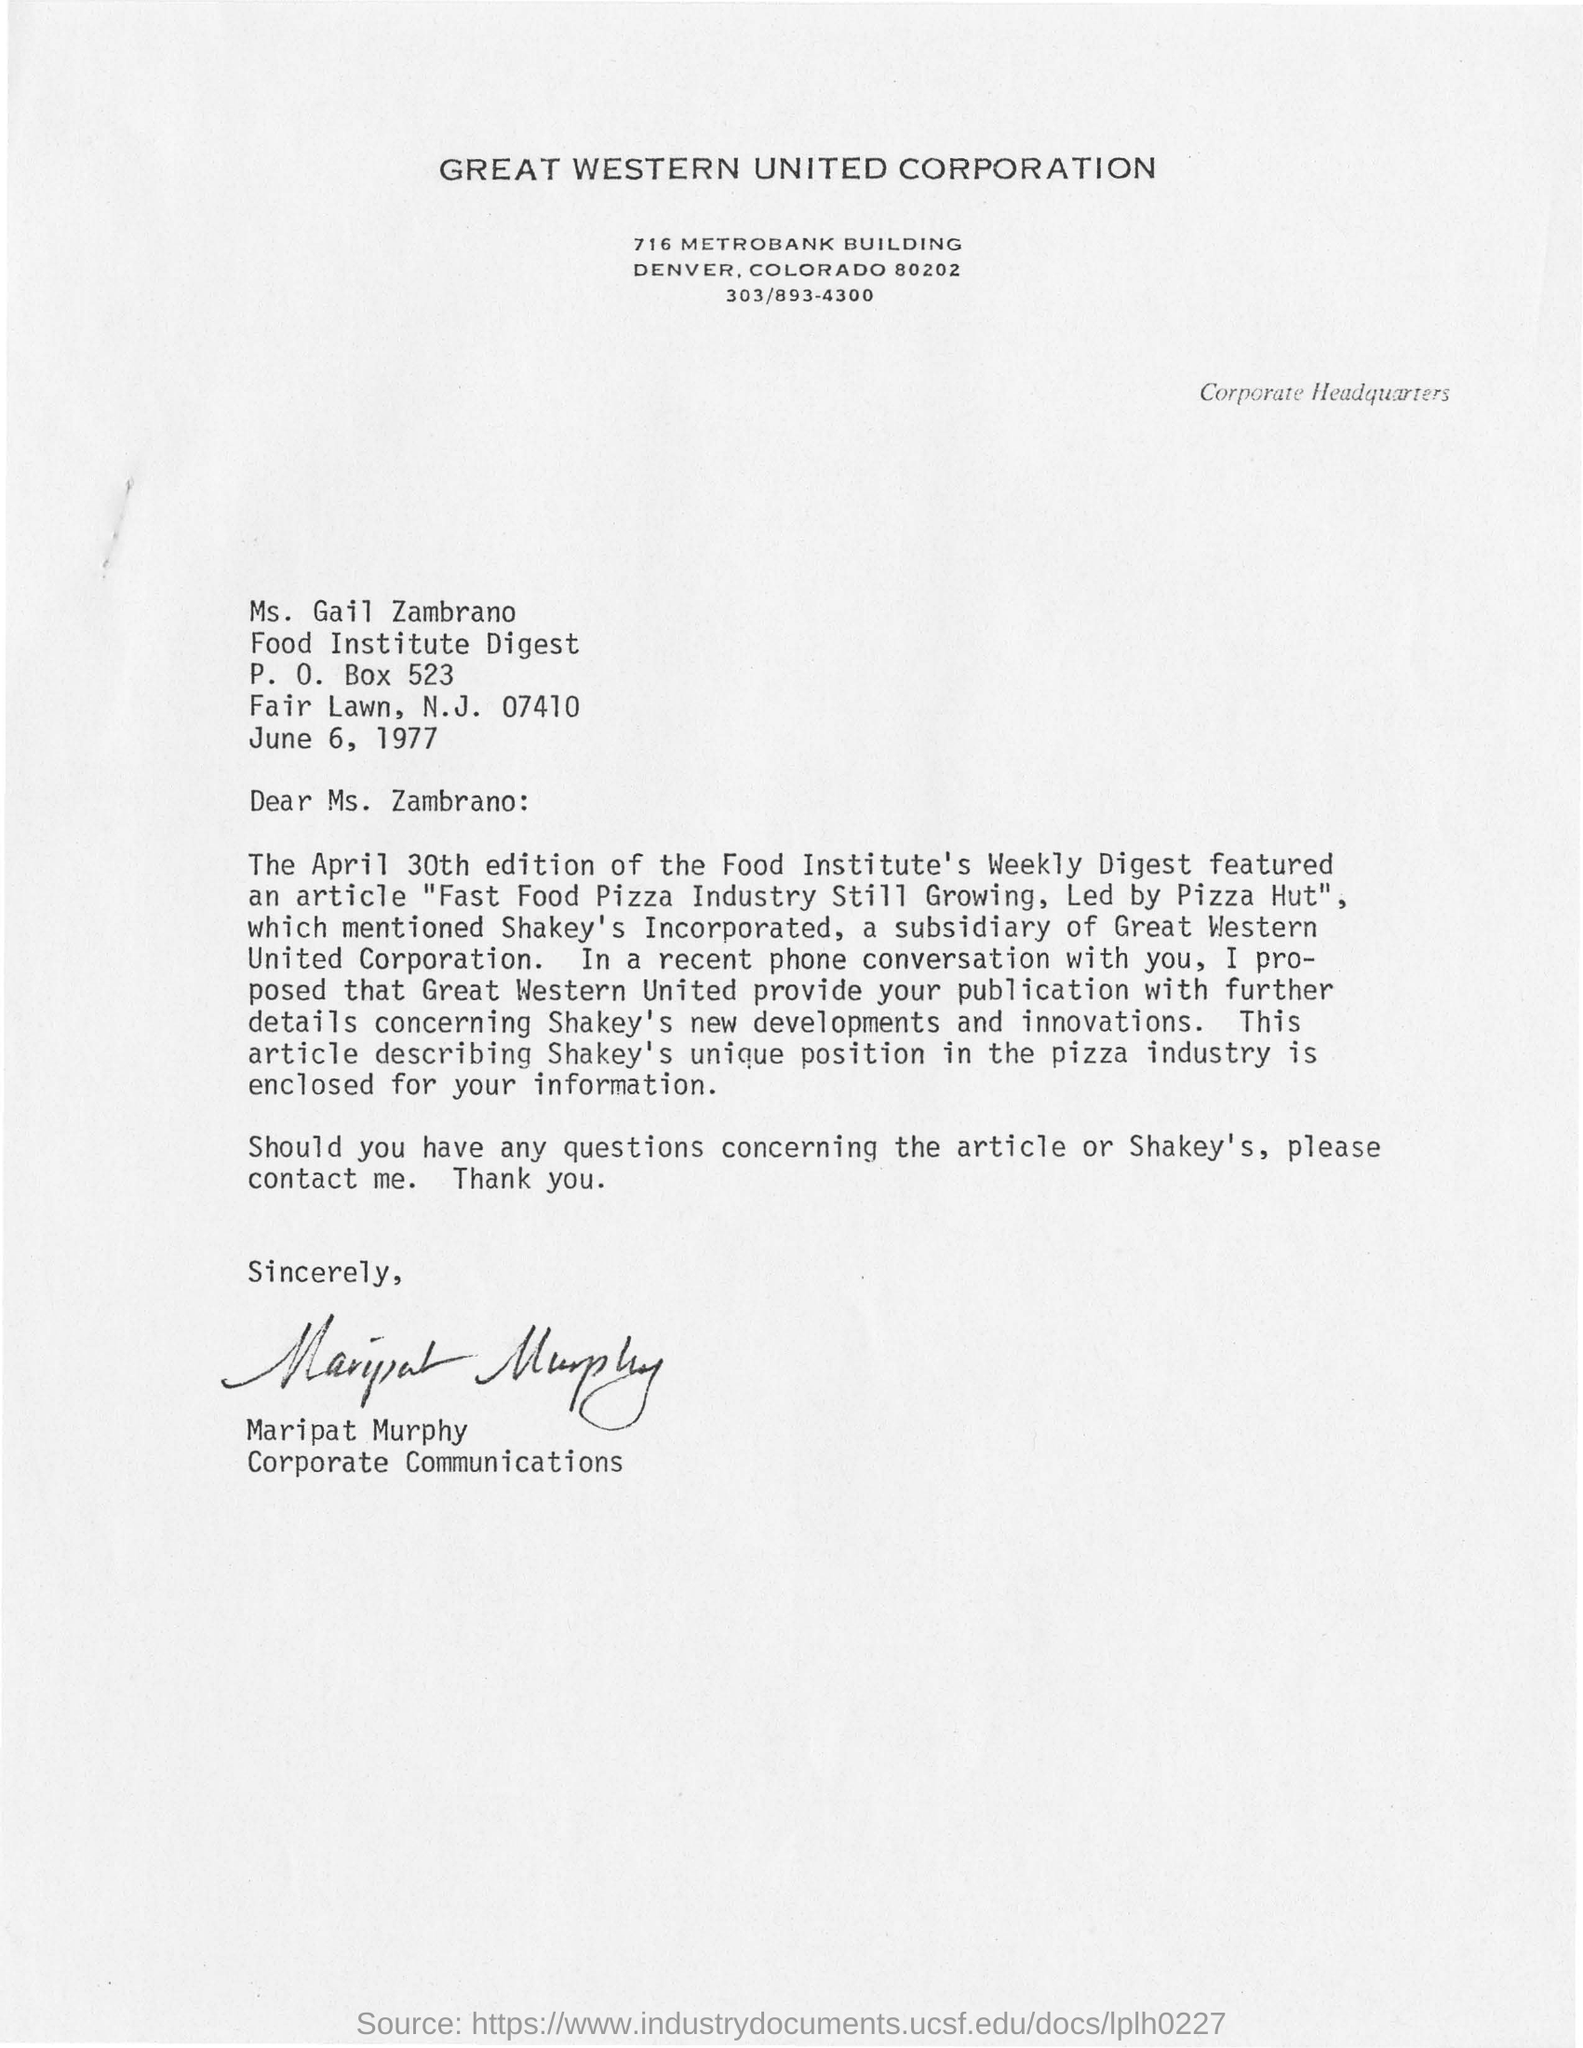Who has signed this letter?
Give a very brief answer. Maripat Murphy. 